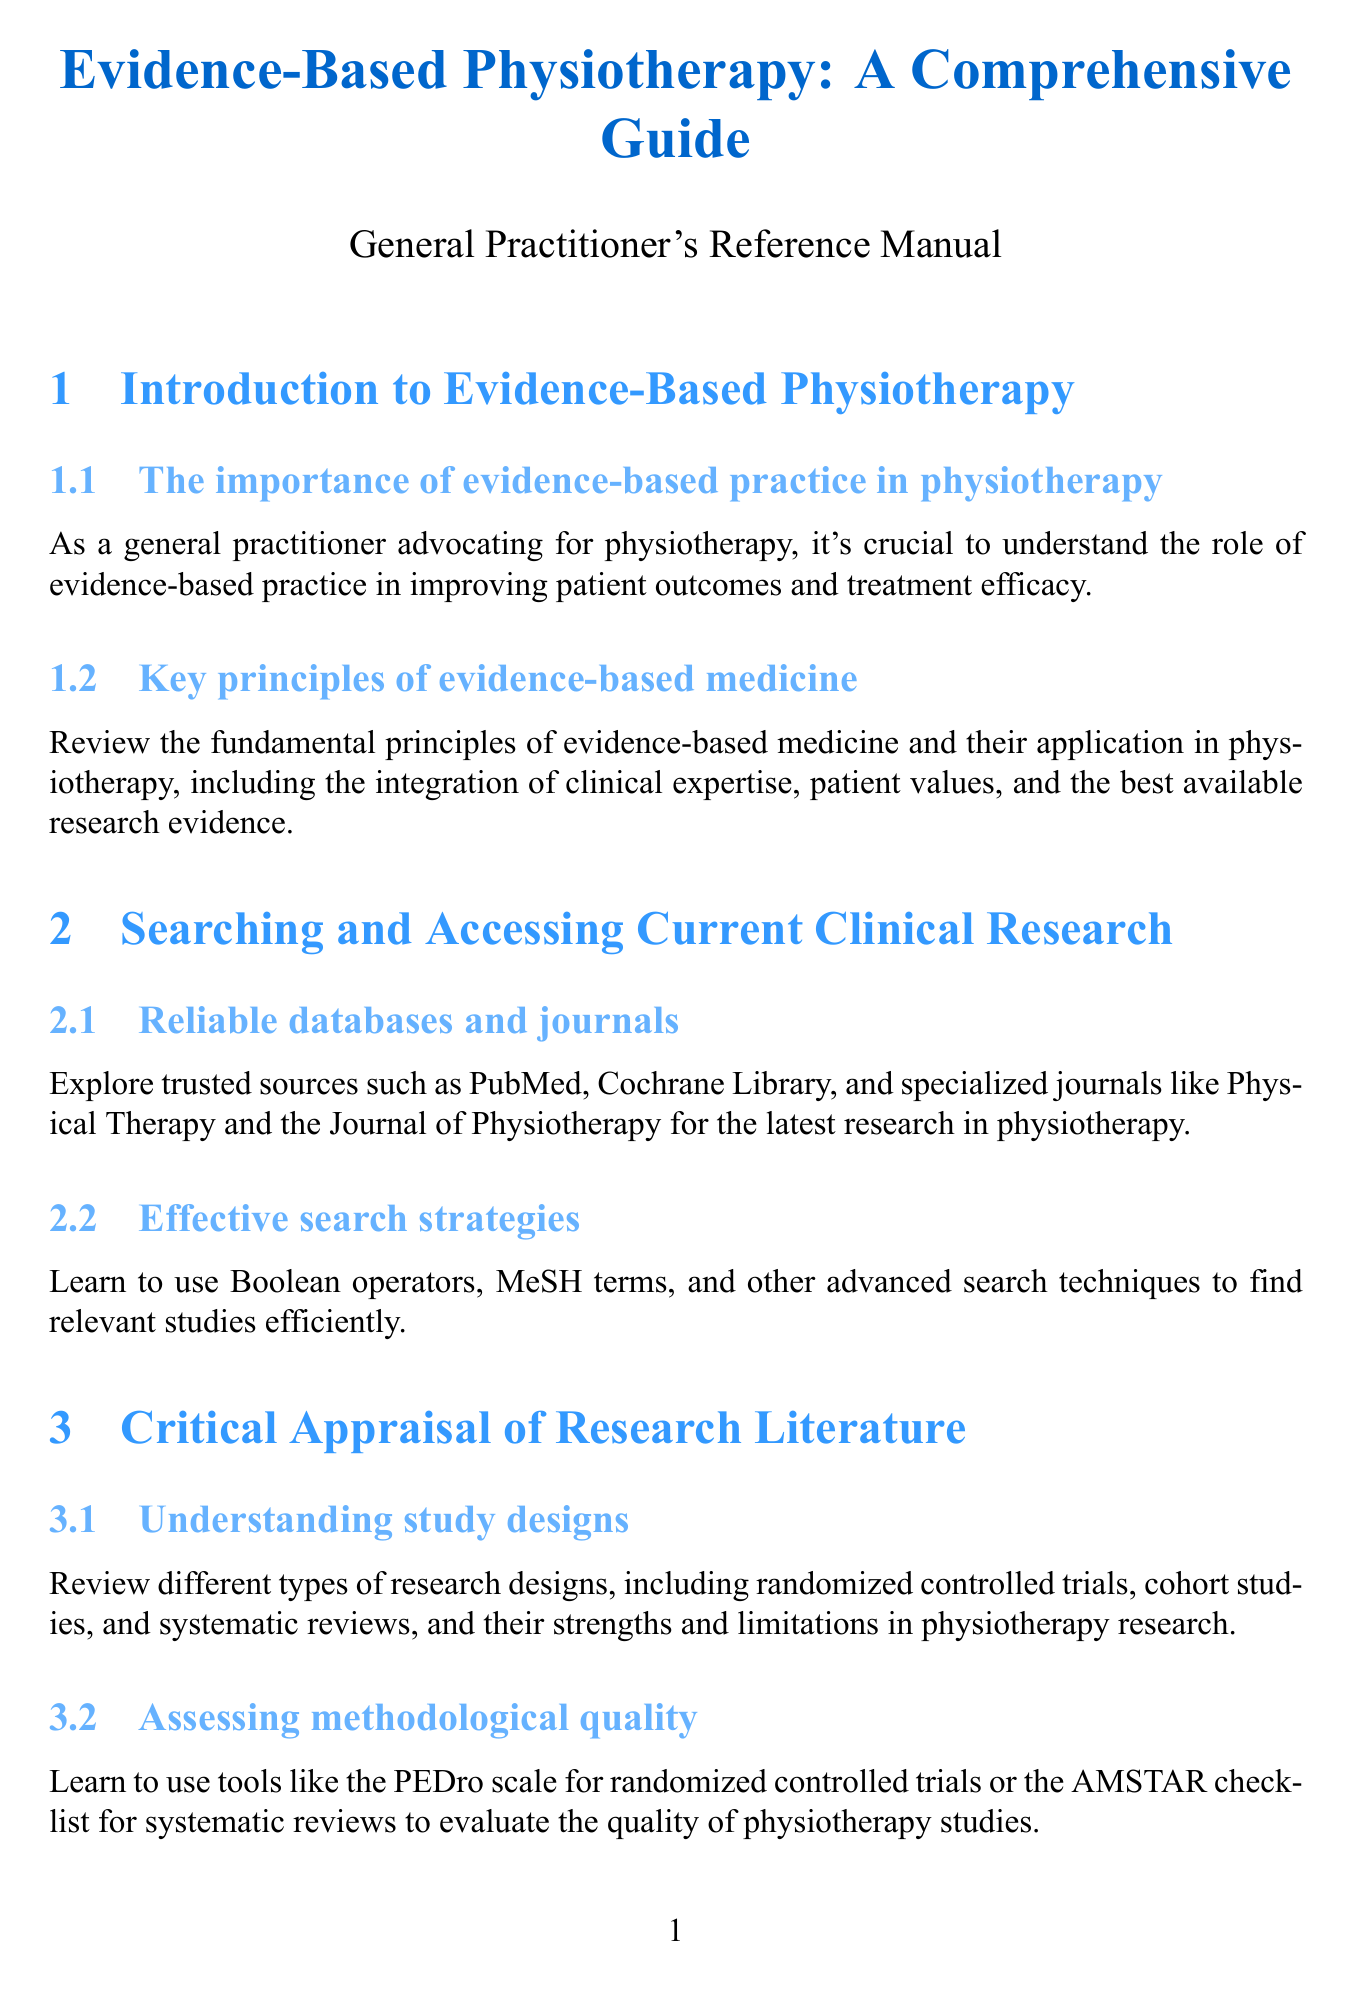What is the title of the guide? The title provides the focus of the document, which is about physiotherapy practices.
Answer: Evidence-Based Physiotherapy: A Comprehensive Guide How many sections are there in the manual? The number of sections gives an idea of the topics covered in the document, which is structured to address key areas.
Answer: 8 What is the purpose of the PEDro scale? The PEDro scale is critical for evaluating the methodological quality of studies in physiotherapy research.
Answer: Assessing methodological quality Which database is mentioned for reliable research sources? This database is widely recognized for its extensive medical literature.
Answer: PubMed What outcome measure is recommended for low back pain? Identifying specific measures helps in understanding the evaluation of treatment efficacy.
Answer: Roland-Morris Disability Questionnaire What is a key strategy for staying current with research? This technique allows practitioners to receive real-time updates on new findings in their field.
Answer: Utilizing technology for research updates What are the two main components of shared decision-making? Understanding these components helps guide patient-centered treatment planning.
Answer: Evidence-based recommendations and patient preferences How can physiotherapy treatments be communicated to other healthcare professionals? This approach ensures effective information sharing among healthcare providers.
Answer: Interprofessional communication 